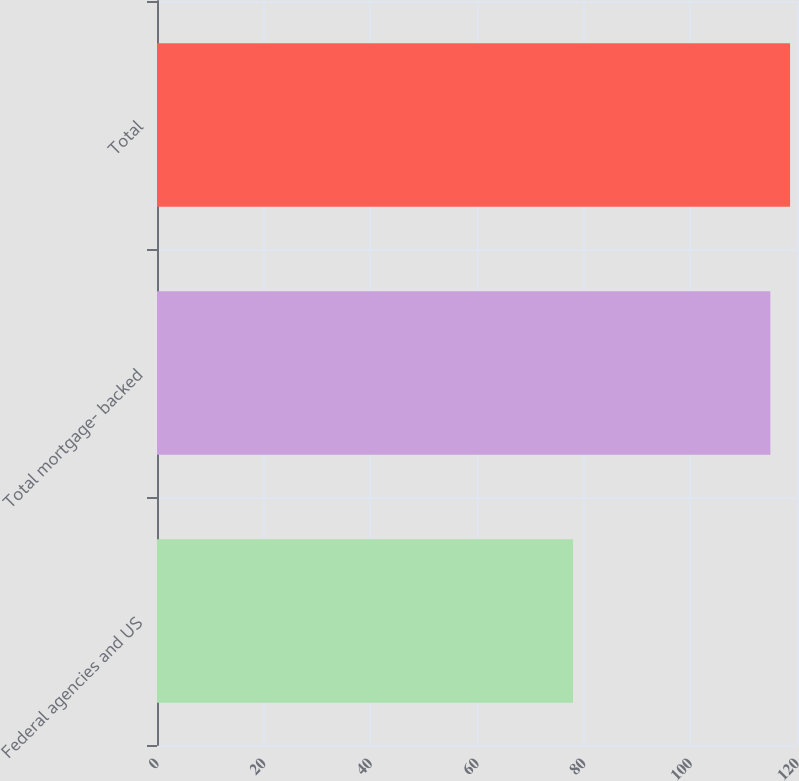Convert chart to OTSL. <chart><loc_0><loc_0><loc_500><loc_500><bar_chart><fcel>Federal agencies and US<fcel>Total mortgage- backed<fcel>Total<nl><fcel>78<fcel>115<fcel>118.7<nl></chart> 